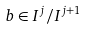Convert formula to latex. <formula><loc_0><loc_0><loc_500><loc_500>b \in I ^ { j } / I ^ { j + 1 }</formula> 